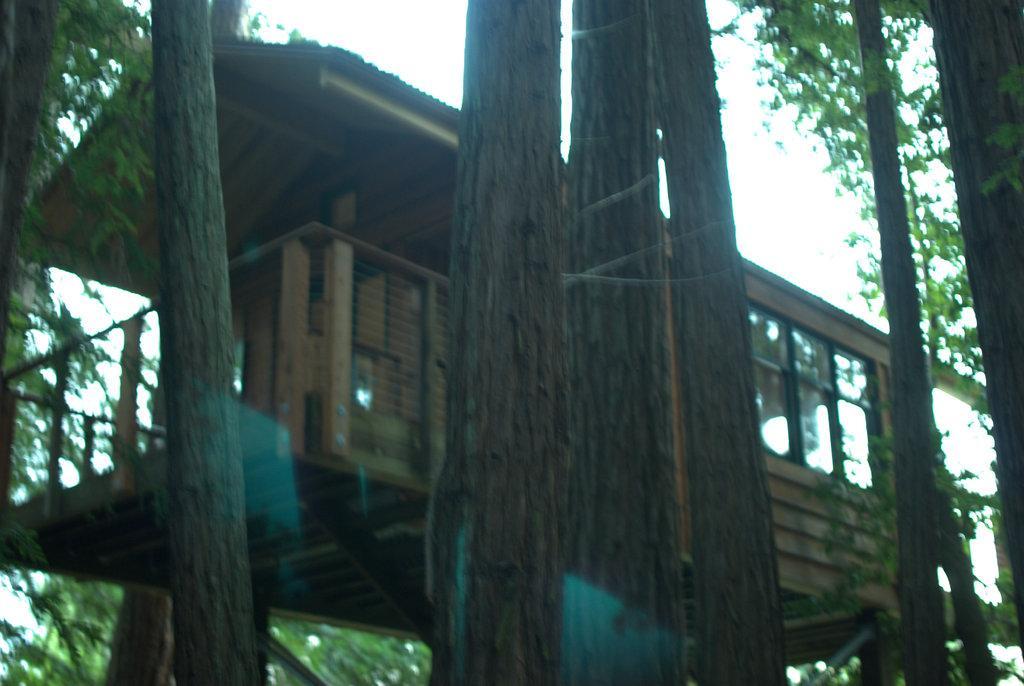In one or two sentences, can you explain what this image depicts? In this image we can see many trees. Also there is a tree house. In the background there is sky. 